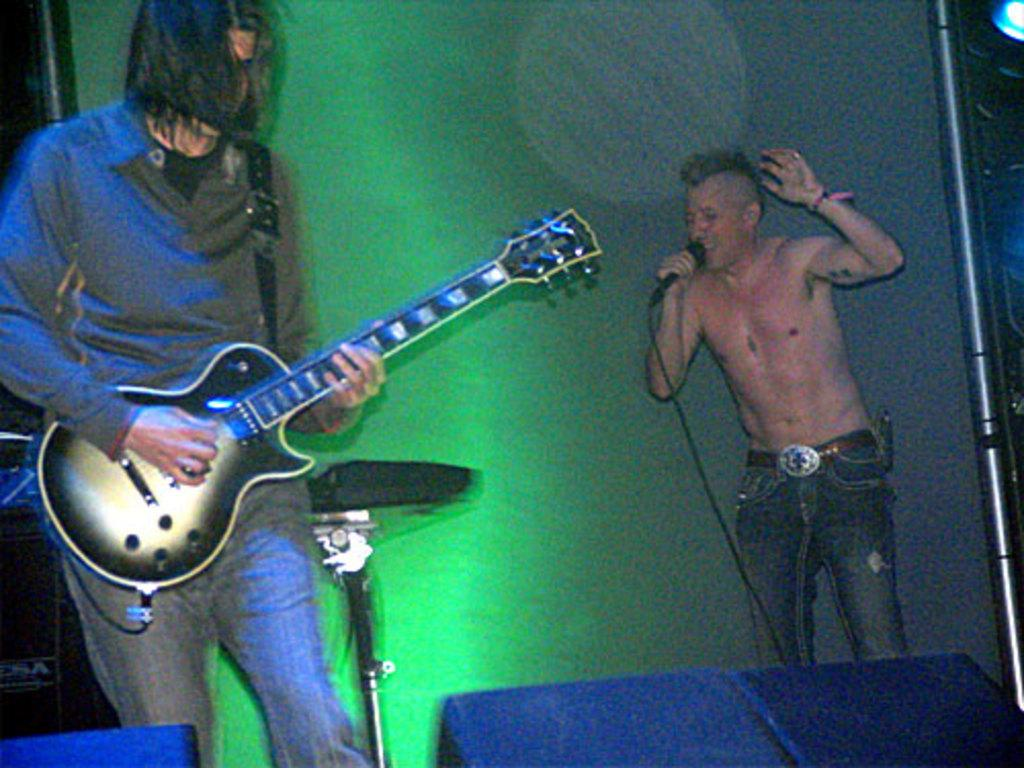What is the main subject of the image? There is a person in the image. What is the person doing in the image? The person is standing and playing a guitar. Is the person performing any vocal activity in the image? Yes, the person is singing in front of a microphone. How many icicles are hanging from the person's guitar in the image? There are no icicles present in the image; the person is playing a guitar without any icicles hanging from it. 